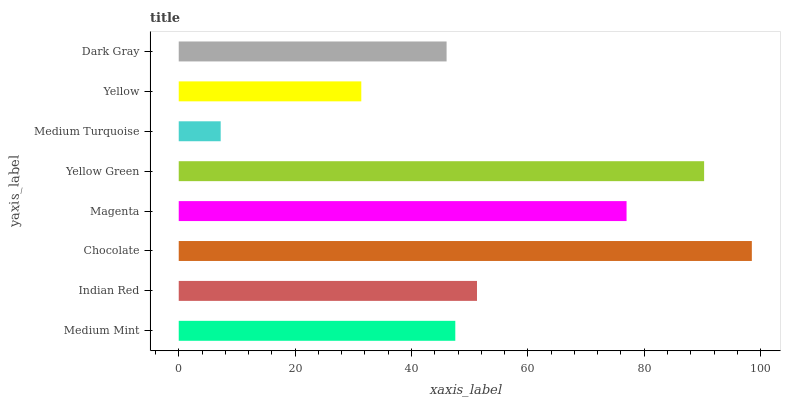Is Medium Turquoise the minimum?
Answer yes or no. Yes. Is Chocolate the maximum?
Answer yes or no. Yes. Is Indian Red the minimum?
Answer yes or no. No. Is Indian Red the maximum?
Answer yes or no. No. Is Indian Red greater than Medium Mint?
Answer yes or no. Yes. Is Medium Mint less than Indian Red?
Answer yes or no. Yes. Is Medium Mint greater than Indian Red?
Answer yes or no. No. Is Indian Red less than Medium Mint?
Answer yes or no. No. Is Indian Red the high median?
Answer yes or no. Yes. Is Medium Mint the low median?
Answer yes or no. Yes. Is Medium Turquoise the high median?
Answer yes or no. No. Is Magenta the low median?
Answer yes or no. No. 